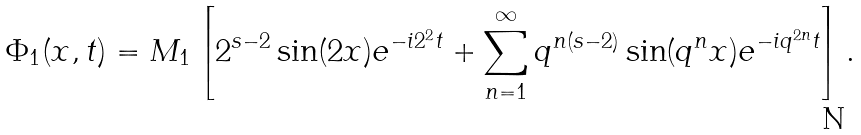<formula> <loc_0><loc_0><loc_500><loc_500>\Phi _ { 1 } ( x , t ) = M _ { 1 } \left [ 2 ^ { s - 2 } \sin ( 2 x ) e ^ { - i 2 ^ { 2 } t } + \sum _ { n = 1 } ^ { \infty } q ^ { n ( s - 2 ) } \sin ( q ^ { n } x ) e ^ { - i q ^ { 2 n } t } \right ] .</formula> 